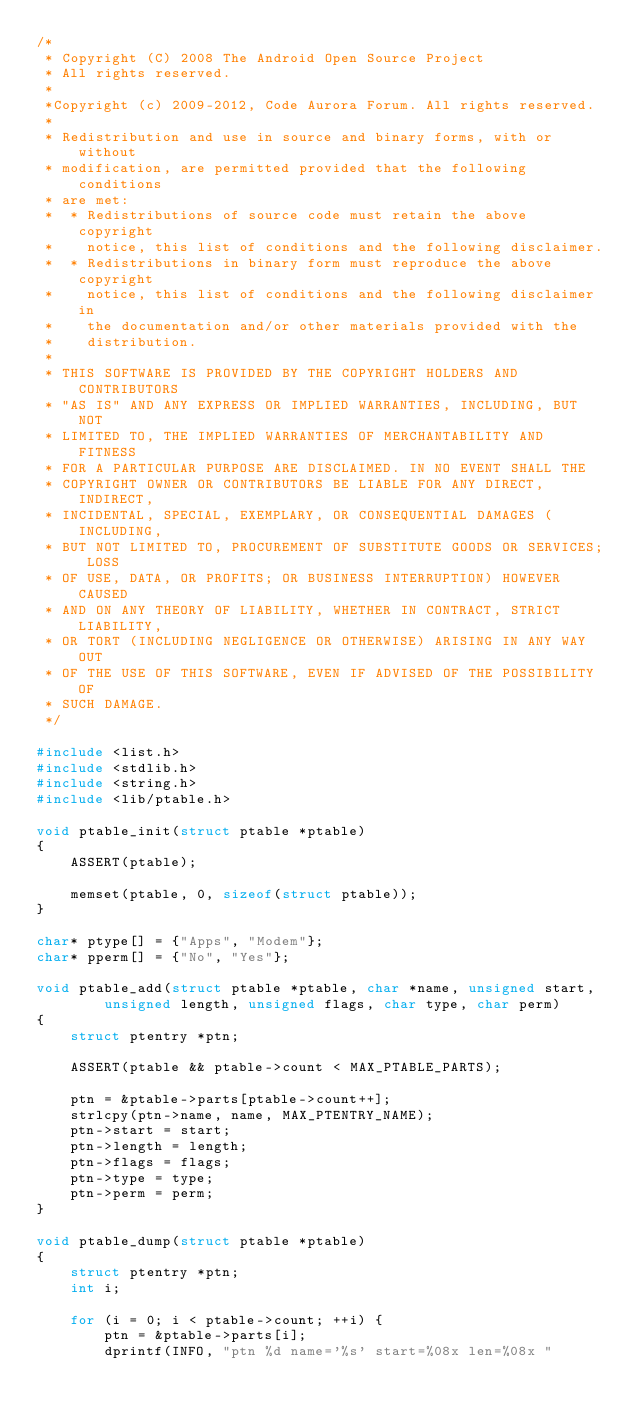Convert code to text. <code><loc_0><loc_0><loc_500><loc_500><_C_>/*
 * Copyright (C) 2008 The Android Open Source Project
 * All rights reserved.
 *
 *Copyright (c) 2009-2012, Code Aurora Forum. All rights reserved.
 *
 * Redistribution and use in source and binary forms, with or without
 * modification, are permitted provided that the following conditions
 * are met:
 *  * Redistributions of source code must retain the above copyright
 *    notice, this list of conditions and the following disclaimer.
 *  * Redistributions in binary form must reproduce the above copyright
 *    notice, this list of conditions and the following disclaimer in
 *    the documentation and/or other materials provided with the 
 *    distribution.
 *
 * THIS SOFTWARE IS PROVIDED BY THE COPYRIGHT HOLDERS AND CONTRIBUTORS
 * "AS IS" AND ANY EXPRESS OR IMPLIED WARRANTIES, INCLUDING, BUT NOT
 * LIMITED TO, THE IMPLIED WARRANTIES OF MERCHANTABILITY AND FITNESS
 * FOR A PARTICULAR PURPOSE ARE DISCLAIMED. IN NO EVENT SHALL THE
 * COPYRIGHT OWNER OR CONTRIBUTORS BE LIABLE FOR ANY DIRECT, INDIRECT,
 * INCIDENTAL, SPECIAL, EXEMPLARY, OR CONSEQUENTIAL DAMAGES (INCLUDING,
 * BUT NOT LIMITED TO, PROCUREMENT OF SUBSTITUTE GOODS OR SERVICES; LOSS
 * OF USE, DATA, OR PROFITS; OR BUSINESS INTERRUPTION) HOWEVER CAUSED 
 * AND ON ANY THEORY OF LIABILITY, WHETHER IN CONTRACT, STRICT LIABILITY,
 * OR TORT (INCLUDING NEGLIGENCE OR OTHERWISE) ARISING IN ANY WAY OUT
 * OF THE USE OF THIS SOFTWARE, EVEN IF ADVISED OF THE POSSIBILITY OF
 * SUCH DAMAGE.
 */

#include <list.h>
#include <stdlib.h>
#include <string.h>
#include <lib/ptable.h>

void ptable_init(struct ptable *ptable)
{
	ASSERT(ptable);

	memset(ptable, 0, sizeof(struct ptable));
}

char* ptype[] = {"Apps", "Modem"};
char* pperm[] = {"No", "Yes"};

void ptable_add(struct ptable *ptable, char *name, unsigned start,
		unsigned length, unsigned flags, char type, char perm)
{
	struct ptentry *ptn;

	ASSERT(ptable && ptable->count < MAX_PTABLE_PARTS);

	ptn = &ptable->parts[ptable->count++];
	strlcpy(ptn->name, name, MAX_PTENTRY_NAME);
	ptn->start = start;
	ptn->length = length;
	ptn->flags = flags;
	ptn->type = type;
	ptn->perm = perm;
}

void ptable_dump(struct ptable *ptable)
{
	struct ptentry *ptn;
	int i;

	for (i = 0; i < ptable->count; ++i) {
		ptn = &ptable->parts[i];
		dprintf(INFO, "ptn %d name='%s' start=%08x len=%08x "</code> 